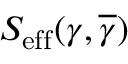<formula> <loc_0><loc_0><loc_500><loc_500>S _ { e f f } ( \gamma , \overline { \gamma } )</formula> 